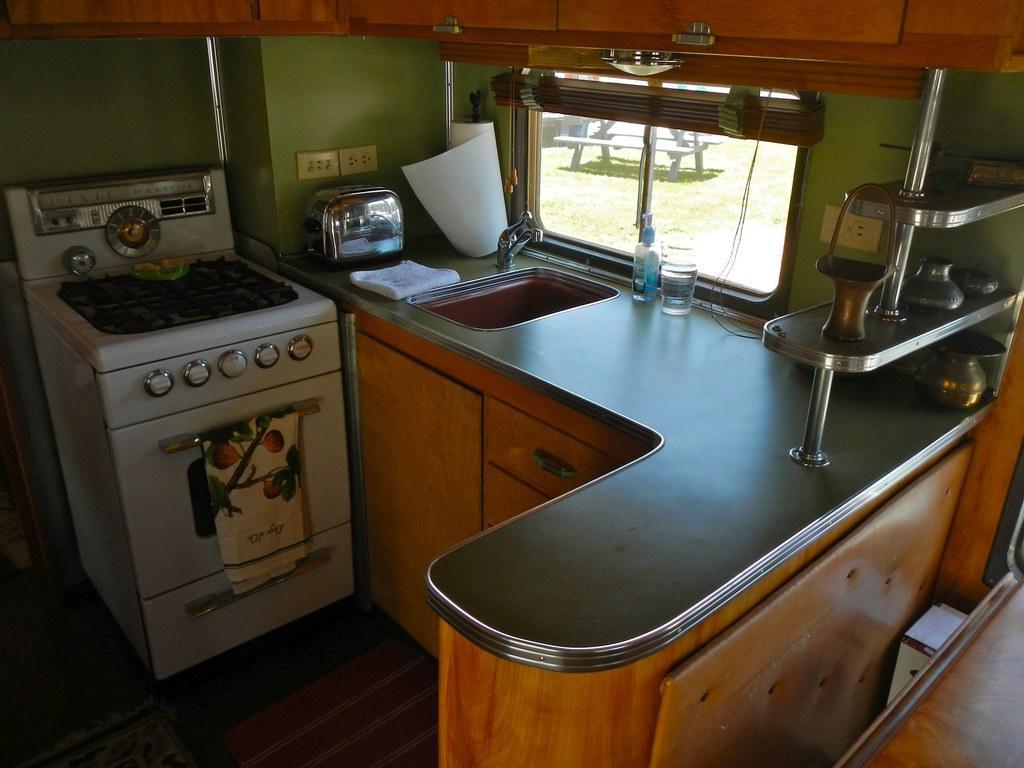Could you give a brief overview of what you see in this image? Here we can see a stove, oven, cloth, roaster, wash basin, tap, and bottles. There are cupboards and this is floor. Here we can see a window. From the window we can see a bench and this is wall. 